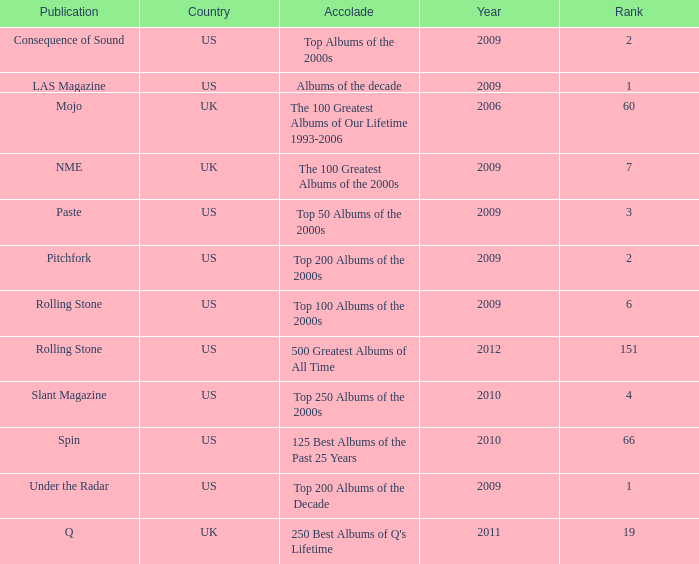What country had a paste publication in 2009? US. 